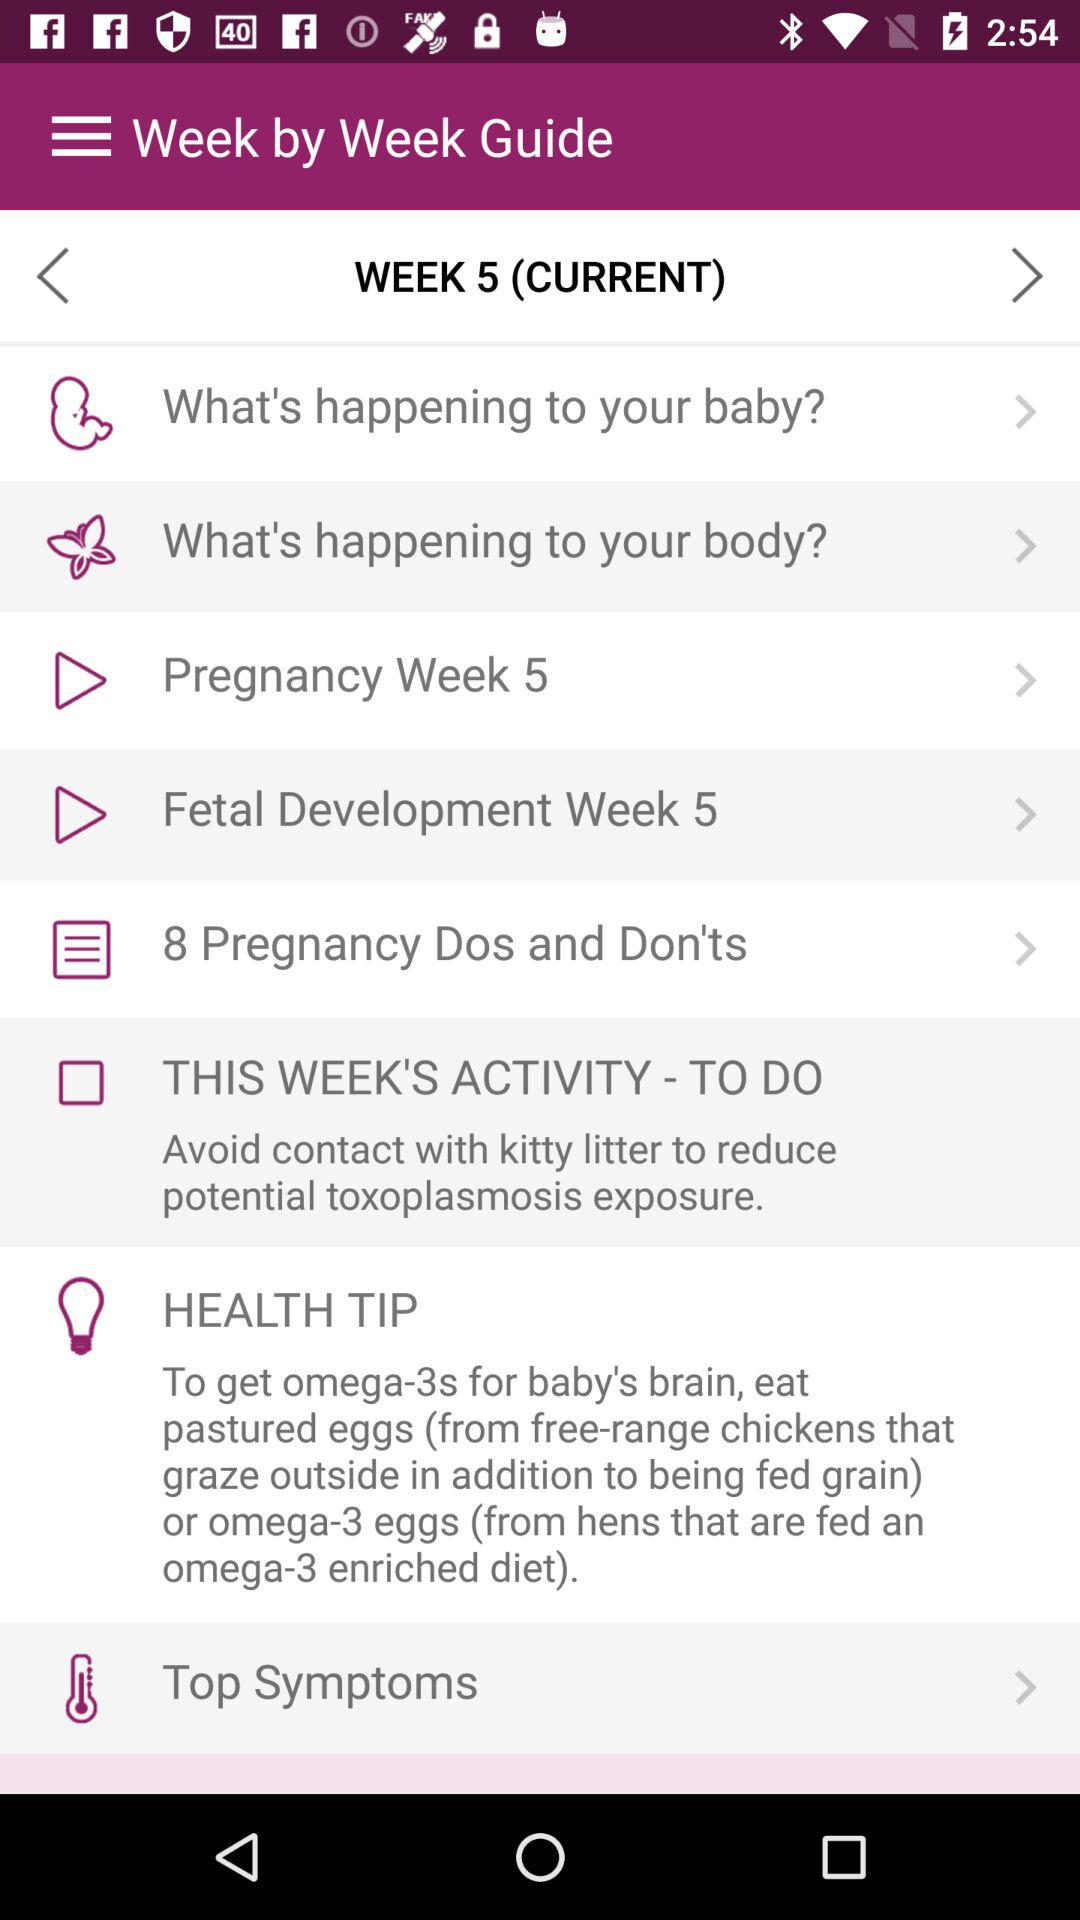What's the "Current Week"? The "Current Week" is 5. 